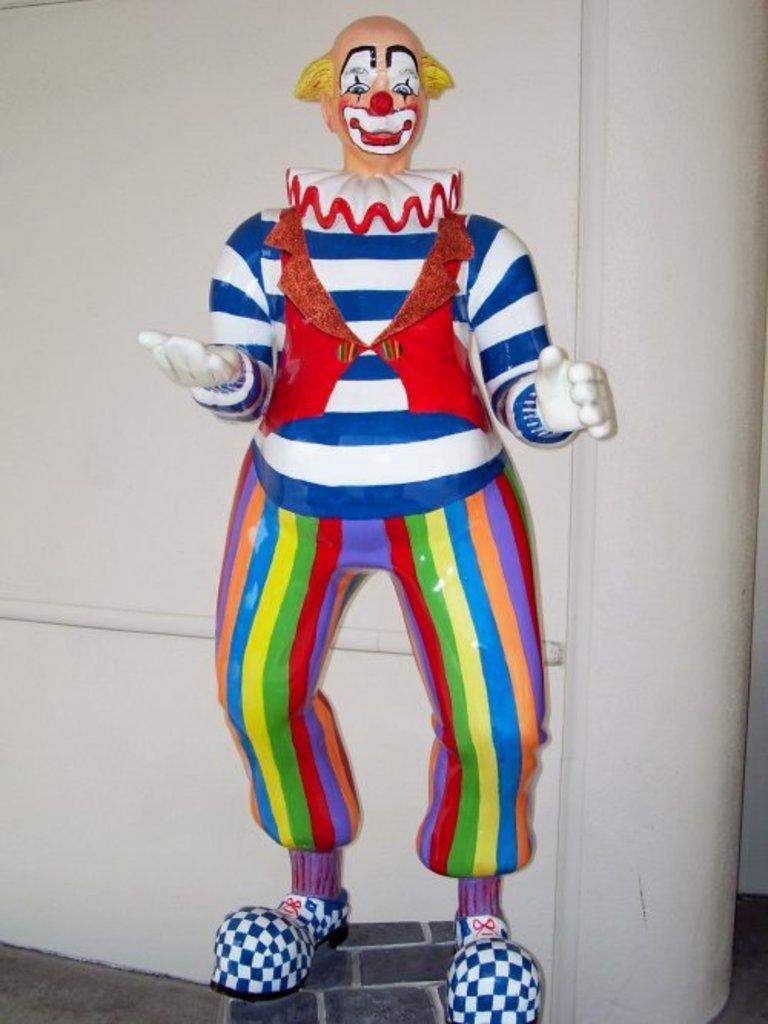In one or two sentences, can you explain what this image depicts? In this image there is a toy, in the background there is the wall. 